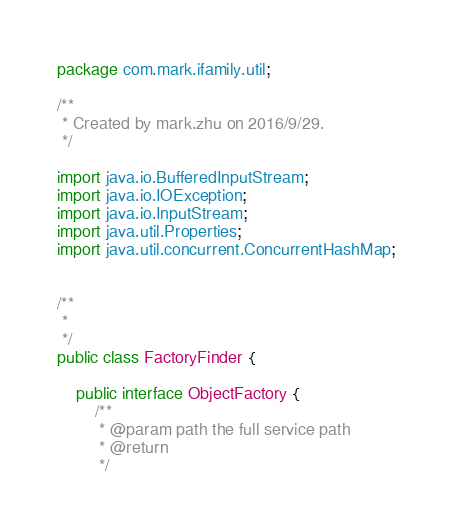<code> <loc_0><loc_0><loc_500><loc_500><_Java_>package com.mark.ifamily.util;

/**
 * Created by mark.zhu on 2016/9/29.
 */

import java.io.BufferedInputStream;
import java.io.IOException;
import java.io.InputStream;
import java.util.Properties;
import java.util.concurrent.ConcurrentHashMap;


/**
 *
 */
public class FactoryFinder {

    public interface ObjectFactory {
        /**
         * @param path the full service path
         * @return
         */</code> 